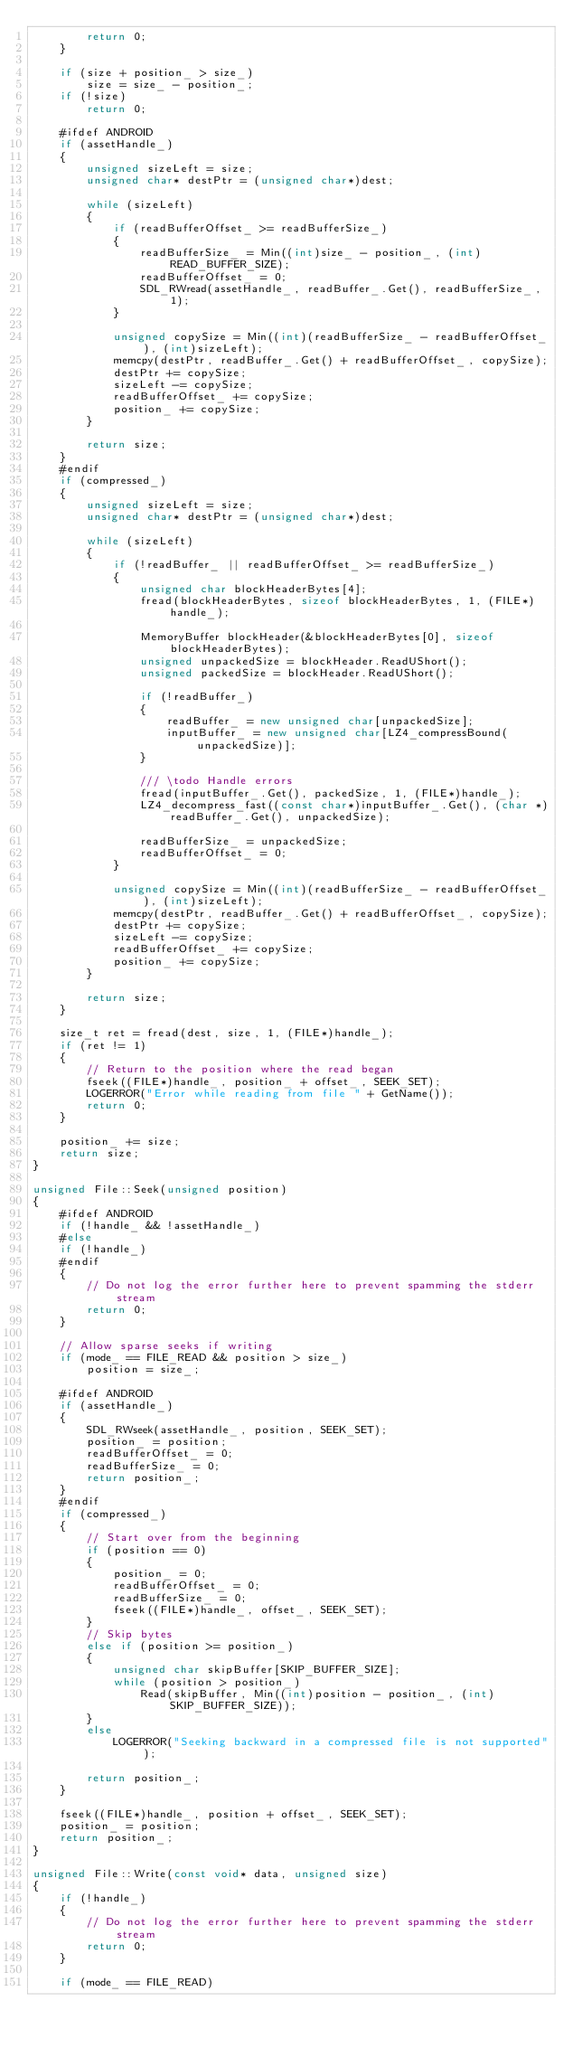<code> <loc_0><loc_0><loc_500><loc_500><_C++_>        return 0;
    }

    if (size + position_ > size_)
        size = size_ - position_;
    if (!size)
        return 0;

    #ifdef ANDROID
    if (assetHandle_)
    {
        unsigned sizeLeft = size;
        unsigned char* destPtr = (unsigned char*)dest;

        while (sizeLeft)
        {
            if (readBufferOffset_ >= readBufferSize_)
            {
                readBufferSize_ = Min((int)size_ - position_, (int)READ_BUFFER_SIZE);
                readBufferOffset_ = 0;
                SDL_RWread(assetHandle_, readBuffer_.Get(), readBufferSize_, 1);
            }

            unsigned copySize = Min((int)(readBufferSize_ - readBufferOffset_), (int)sizeLeft);
            memcpy(destPtr, readBuffer_.Get() + readBufferOffset_, copySize);
            destPtr += copySize;
            sizeLeft -= copySize;
            readBufferOffset_ += copySize;
            position_ += copySize;
        }

        return size;
    }
    #endif
    if (compressed_)
    {
        unsigned sizeLeft = size;
        unsigned char* destPtr = (unsigned char*)dest;

        while (sizeLeft)
        {
            if (!readBuffer_ || readBufferOffset_ >= readBufferSize_)
            {
                unsigned char blockHeaderBytes[4];
                fread(blockHeaderBytes, sizeof blockHeaderBytes, 1, (FILE*)handle_);

                MemoryBuffer blockHeader(&blockHeaderBytes[0], sizeof blockHeaderBytes);
                unsigned unpackedSize = blockHeader.ReadUShort();
                unsigned packedSize = blockHeader.ReadUShort();

                if (!readBuffer_)
                {
                    readBuffer_ = new unsigned char[unpackedSize];
                    inputBuffer_ = new unsigned char[LZ4_compressBound(unpackedSize)];
                }

                /// \todo Handle errors
                fread(inputBuffer_.Get(), packedSize, 1, (FILE*)handle_);
                LZ4_decompress_fast((const char*)inputBuffer_.Get(), (char *)readBuffer_.Get(), unpackedSize);

                readBufferSize_ = unpackedSize;
                readBufferOffset_ = 0;
            }

            unsigned copySize = Min((int)(readBufferSize_ - readBufferOffset_), (int)sizeLeft);
            memcpy(destPtr, readBuffer_.Get() + readBufferOffset_, copySize);
            destPtr += copySize;
            sizeLeft -= copySize;
            readBufferOffset_ += copySize;
            position_ += copySize;
        }

        return size;
    }

    size_t ret = fread(dest, size, 1, (FILE*)handle_);
    if (ret != 1)
    {
        // Return to the position where the read began
        fseek((FILE*)handle_, position_ + offset_, SEEK_SET);
        LOGERROR("Error while reading from file " + GetName());
        return 0;
    }

    position_ += size;
    return size;
}

unsigned File::Seek(unsigned position)
{
    #ifdef ANDROID
    if (!handle_ && !assetHandle_)
    #else
    if (!handle_)
    #endif
    {
        // Do not log the error further here to prevent spamming the stderr stream
        return 0;
    }

    // Allow sparse seeks if writing
    if (mode_ == FILE_READ && position > size_)
        position = size_;

    #ifdef ANDROID
    if (assetHandle_)
    {
        SDL_RWseek(assetHandle_, position, SEEK_SET);
        position_ = position;
        readBufferOffset_ = 0;
        readBufferSize_ = 0;
        return position_;
    }
    #endif
    if (compressed_)
    {
        // Start over from the beginning
        if (position == 0)
        {
            position_ = 0;
            readBufferOffset_ = 0;
            readBufferSize_ = 0;
            fseek((FILE*)handle_, offset_, SEEK_SET);
        }
        // Skip bytes
        else if (position >= position_)
        {
            unsigned char skipBuffer[SKIP_BUFFER_SIZE];
            while (position > position_)
                Read(skipBuffer, Min((int)position - position_, (int)SKIP_BUFFER_SIZE));
        }
        else
            LOGERROR("Seeking backward in a compressed file is not supported");

        return position_;
    }

    fseek((FILE*)handle_, position + offset_, SEEK_SET);
    position_ = position;
    return position_;
}

unsigned File::Write(const void* data, unsigned size)
{
    if (!handle_)
    {
        // Do not log the error further here to prevent spamming the stderr stream
        return 0;
    }

    if (mode_ == FILE_READ)</code> 